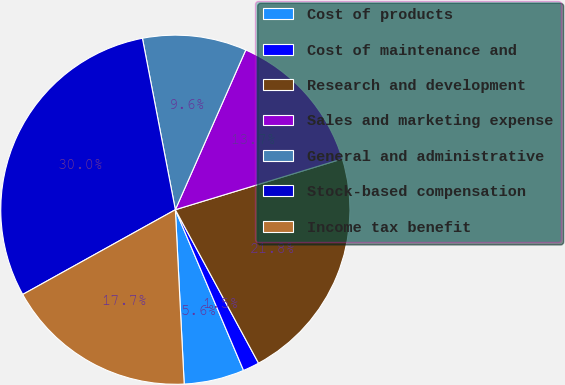Convert chart. <chart><loc_0><loc_0><loc_500><loc_500><pie_chart><fcel>Cost of products<fcel>Cost of maintenance and<fcel>Research and development<fcel>Sales and marketing expense<fcel>General and administrative<fcel>Stock-based compensation<fcel>Income tax benefit<nl><fcel>5.58%<fcel>1.52%<fcel>21.8%<fcel>13.69%<fcel>9.63%<fcel>30.05%<fcel>17.74%<nl></chart> 